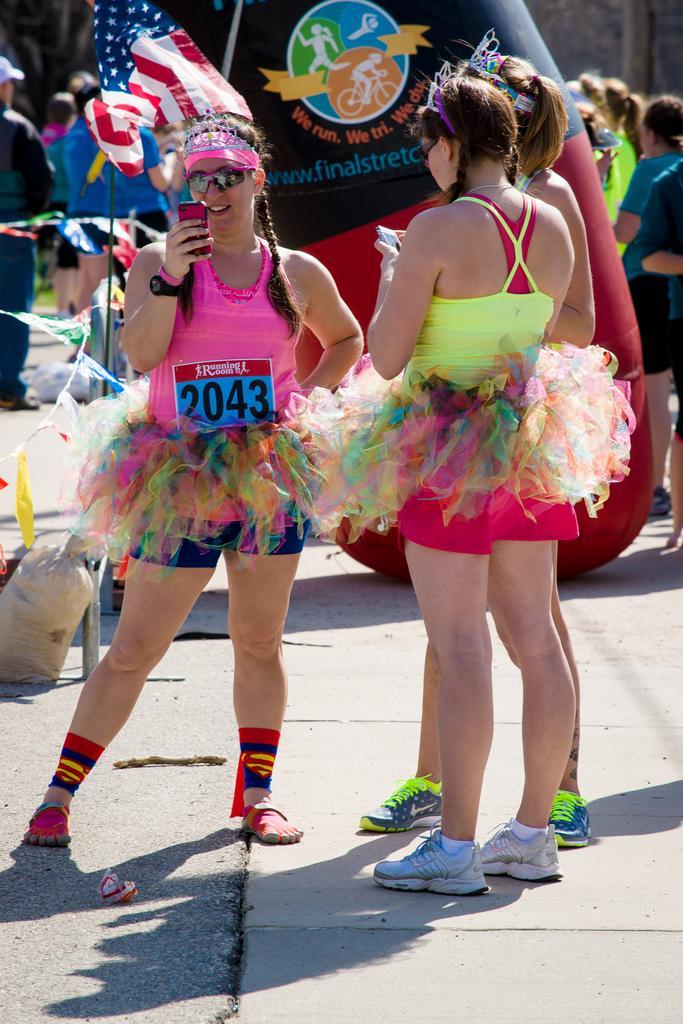How would you summarize this image in a sentence or two? In this image we can see a few people, among them, some people are holding the objects, also we can see a bag, flag and some other objects. 